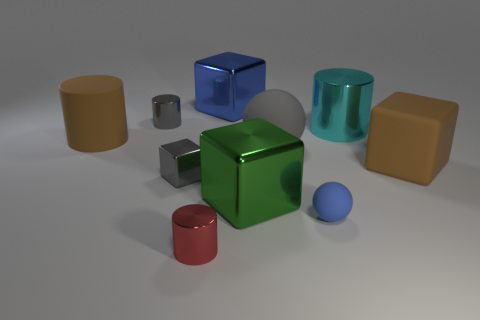How many other objects are there of the same color as the tiny rubber sphere?
Your response must be concise. 1. There is a small metal object that is behind the large cyan cylinder; does it have the same color as the matte sphere that is behind the gray metal block?
Keep it short and to the point. Yes. There is a large brown rubber cylinder; are there any big rubber things on the left side of it?
Ensure brevity in your answer.  No. How many large cyan objects are the same shape as the small red thing?
Ensure brevity in your answer.  1. The big object in front of the brown rubber object that is on the right side of the small red shiny cylinder that is to the left of the large ball is what color?
Your answer should be compact. Green. Do the sphere that is behind the gray shiny block and the blue thing left of the small rubber sphere have the same material?
Give a very brief answer. No. How many things are things to the left of the big blue thing or big brown blocks?
Offer a terse response. 5. What number of objects are blue balls or big things left of the large cyan object?
Give a very brief answer. 5. How many red cylinders are the same size as the green shiny block?
Provide a short and direct response. 0. Are there fewer big green shiny objects that are behind the large cyan cylinder than large blocks that are in front of the large blue object?
Keep it short and to the point. Yes. 